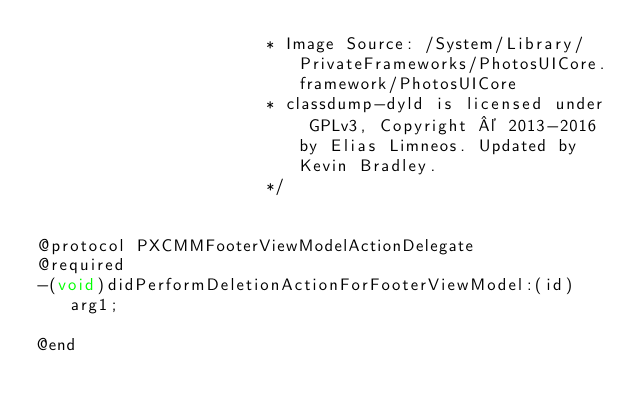<code> <loc_0><loc_0><loc_500><loc_500><_C_>                       * Image Source: /System/Library/PrivateFrameworks/PhotosUICore.framework/PhotosUICore
                       * classdump-dyld is licensed under GPLv3, Copyright © 2013-2016 by Elias Limneos. Updated by Kevin Bradley.
                       */


@protocol PXCMMFooterViewModelActionDelegate
@required
-(void)didPerformDeletionActionForFooterViewModel:(id)arg1;

@end

</code> 